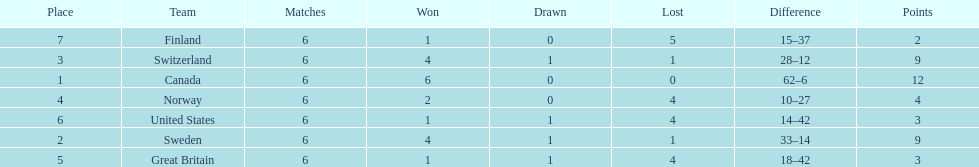What was the number of points won by great britain? 3. I'm looking to parse the entire table for insights. Could you assist me with that? {'header': ['Place', 'Team', 'Matches', 'Won', 'Drawn', 'Lost', 'Difference', 'Points'], 'rows': [['7', 'Finland', '6', '1', '0', '5', '15–37', '2'], ['3', 'Switzerland', '6', '4', '1', '1', '28–12', '9'], ['1', 'Canada', '6', '6', '0', '0', '62–6', '12'], ['4', 'Norway', '6', '2', '0', '4', '10–27', '4'], ['6', 'United States', '6', '1', '1', '4', '14–42', '3'], ['2', 'Sweden', '6', '4', '1', '1', '33–14', '9'], ['5', 'Great Britain', '6', '1', '1', '4', '18–42', '3']]} 